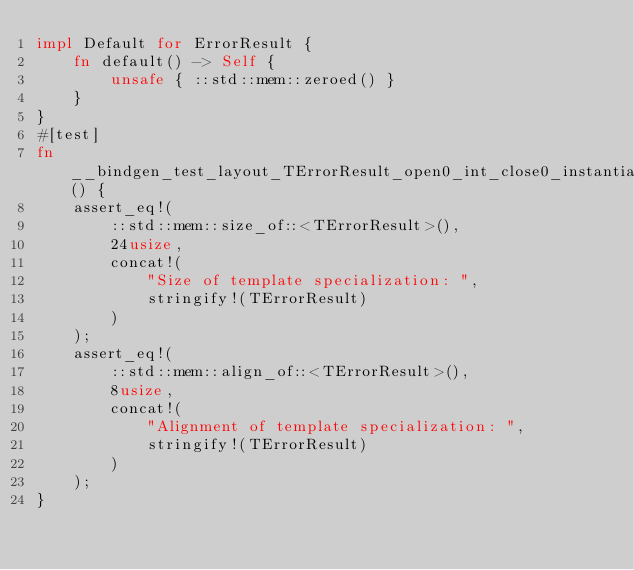Convert code to text. <code><loc_0><loc_0><loc_500><loc_500><_Rust_>impl Default for ErrorResult {
    fn default() -> Self {
        unsafe { ::std::mem::zeroed() }
    }
}
#[test]
fn __bindgen_test_layout_TErrorResult_open0_int_close0_instantiation() {
    assert_eq!(
        ::std::mem::size_of::<TErrorResult>(),
        24usize,
        concat!(
            "Size of template specialization: ",
            stringify!(TErrorResult)
        )
    );
    assert_eq!(
        ::std::mem::align_of::<TErrorResult>(),
        8usize,
        concat!(
            "Alignment of template specialization: ",
            stringify!(TErrorResult)
        )
    );
}
</code> 